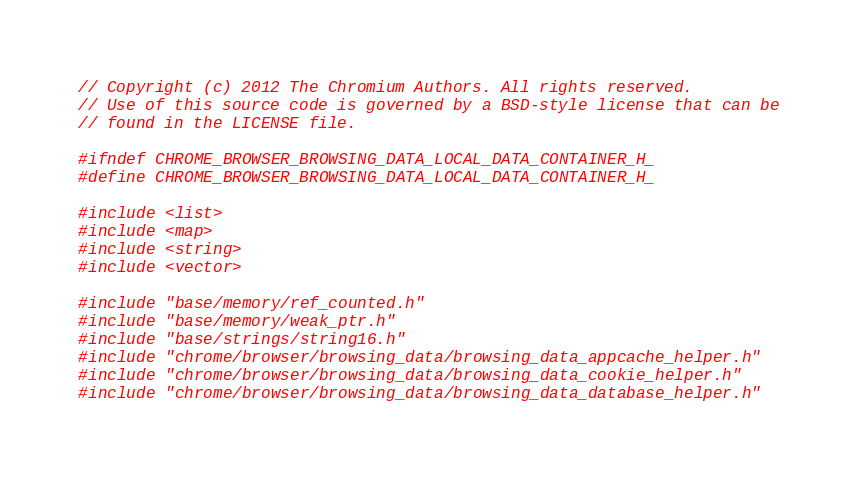Convert code to text. <code><loc_0><loc_0><loc_500><loc_500><_C_>// Copyright (c) 2012 The Chromium Authors. All rights reserved.
// Use of this source code is governed by a BSD-style license that can be
// found in the LICENSE file.

#ifndef CHROME_BROWSER_BROWSING_DATA_LOCAL_DATA_CONTAINER_H_
#define CHROME_BROWSER_BROWSING_DATA_LOCAL_DATA_CONTAINER_H_

#include <list>
#include <map>
#include <string>
#include <vector>

#include "base/memory/ref_counted.h"
#include "base/memory/weak_ptr.h"
#include "base/strings/string16.h"
#include "chrome/browser/browsing_data/browsing_data_appcache_helper.h"
#include "chrome/browser/browsing_data/browsing_data_cookie_helper.h"
#include "chrome/browser/browsing_data/browsing_data_database_helper.h"</code> 